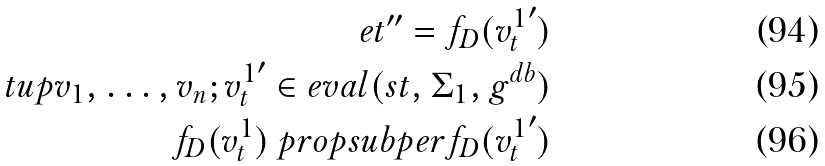<formula> <loc_0><loc_0><loc_500><loc_500>e t ^ { \prime \prime } = f _ { D } ( { v ^ { 1 } _ { t } } ^ { \prime } ) \\ \ t u p { v _ { 1 } , \dots , v _ { n } ; { v ^ { 1 } _ { t } } ^ { \prime } } \in e v a l ( s t , \Sigma _ { 1 } , g ^ { d b } ) \\ f _ { D } ( v ^ { 1 } _ { t } ) \ p r o p s u b p e r f _ { D } ( { v ^ { 1 } _ { t } } ^ { \prime } )</formula> 